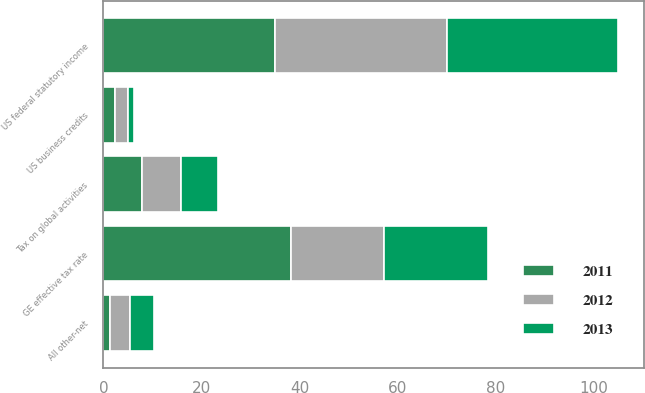Convert chart to OTSL. <chart><loc_0><loc_0><loc_500><loc_500><stacked_bar_chart><ecel><fcel>US federal statutory income<fcel>Tax on global activities<fcel>US business credits<fcel>All other-net<fcel>GE effective tax rate<nl><fcel>2012<fcel>35<fcel>7.9<fcel>2.8<fcel>4.1<fcel>18.9<nl><fcel>2013<fcel>35<fcel>7.6<fcel>1.2<fcel>4.9<fcel>21.3<nl><fcel>2011<fcel>35<fcel>7.9<fcel>2.3<fcel>1.4<fcel>38.3<nl></chart> 